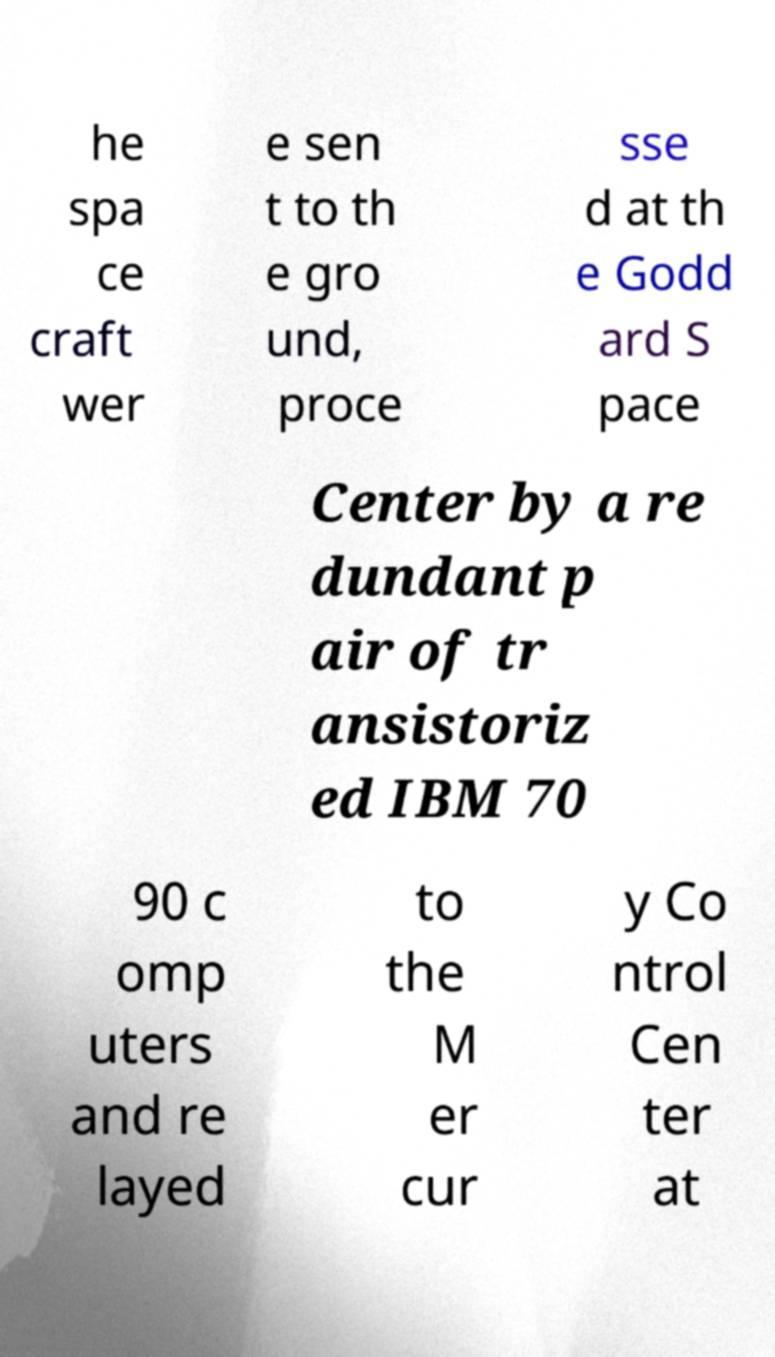Could you extract and type out the text from this image? he spa ce craft wer e sen t to th e gro und, proce sse d at th e Godd ard S pace Center by a re dundant p air of tr ansistoriz ed IBM 70 90 c omp uters and re layed to the M er cur y Co ntrol Cen ter at 